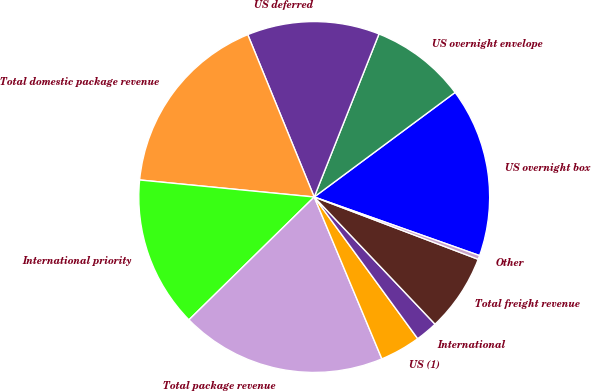Convert chart. <chart><loc_0><loc_0><loc_500><loc_500><pie_chart><fcel>US overnight box<fcel>US overnight envelope<fcel>US deferred<fcel>Total domestic package revenue<fcel>International priority<fcel>Total package revenue<fcel>US (1)<fcel>International<fcel>Total freight revenue<fcel>Other<nl><fcel>15.58%<fcel>8.82%<fcel>12.2%<fcel>17.27%<fcel>13.89%<fcel>18.96%<fcel>3.74%<fcel>2.05%<fcel>7.13%<fcel>0.36%<nl></chart> 